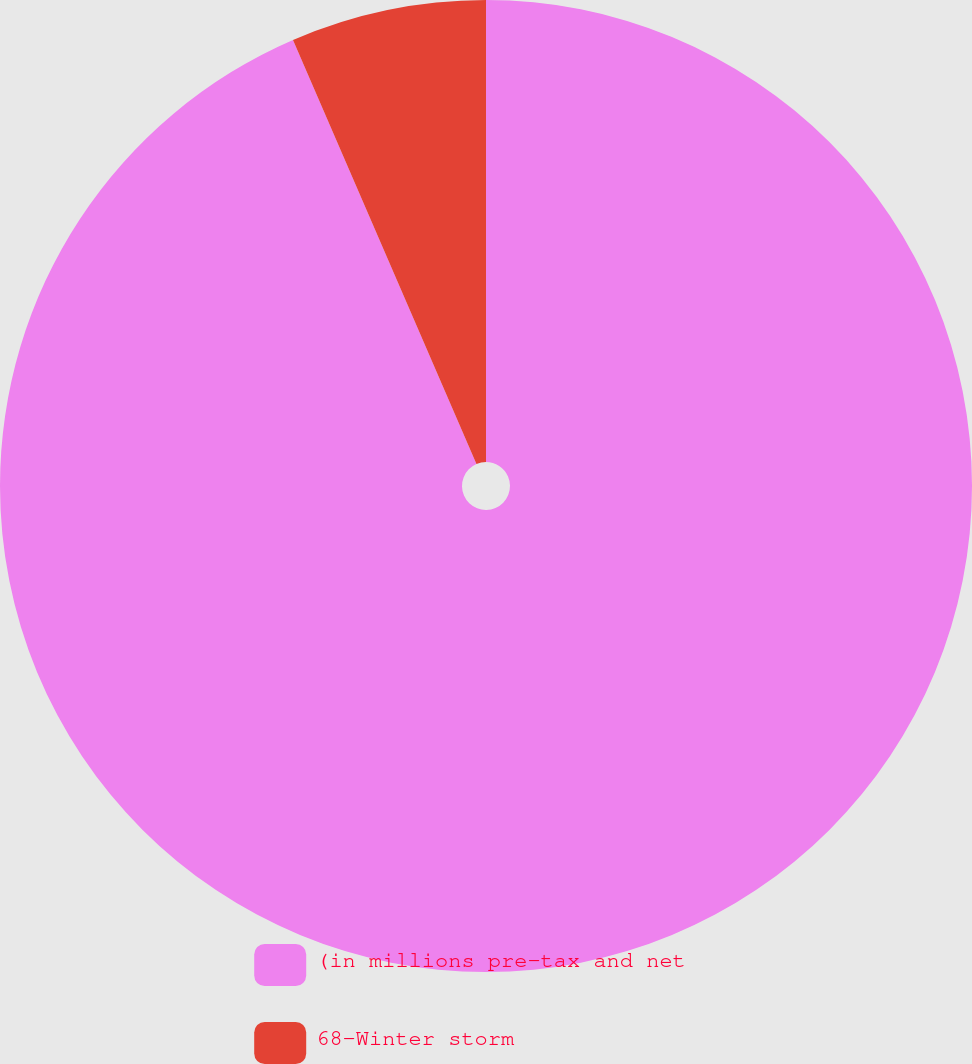Convert chart to OTSL. <chart><loc_0><loc_0><loc_500><loc_500><pie_chart><fcel>(in millions pre-tax and net<fcel>68-Winter storm<nl><fcel>93.5%<fcel>6.5%<nl></chart> 